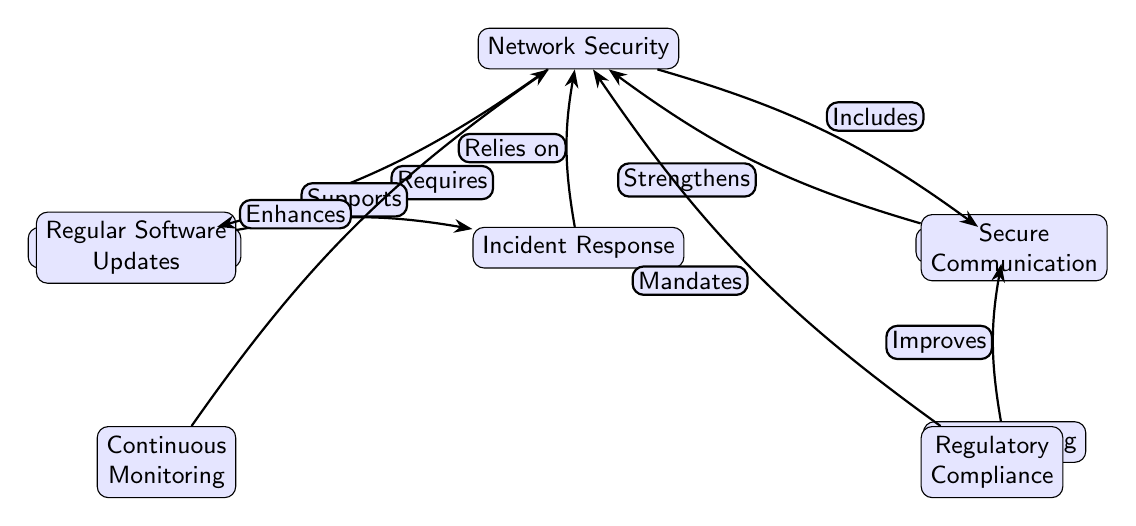What are the components of network security? The diagram identifies two specific components of network security: Device Encryption and Access Control, represented as nodes branching directly from the Network Security node.
Answer: Device Encryption, Access Control How many nodes are there in the diagram? By counting all the distinct elements represented in the diagram, we identify a total of 8 nodes: Network Security, Device Encryption, Access Control, Incident Response, Regular Software Updates, Secure Communication, Continuous Monitoring, User Training, and Regulatory Compliance.
Answer: 8 Which component mandates network security? Compliance is indicated in the diagram as directly linked to Network Security with the label "Mandates," highlighting its role in enforcing security measures within the framework.
Answer: Regulatory Compliance What enhances network security? Continuous Monitoring is directly connected to Network Security with the label "Enhances," suggesting that it plays a significant role in improving the overall security posture.
Answer: Continuous Monitoring Which node relies on incident response? The flowchart shows that Network Security is indicated to "Relies on" Incident Response, implying that incident response practices are crucial for the effective operation of network security measures.
Answer: Network Security How does secure communication relate to network security? The diagram specifies that Secure Communication "Strengthens" Network Security, implying that secure communication protocols contribute to the robustness of the security framework.
Answer: Strengthens What supports incident response? Regular Software Updates is shown in the diagram as contributing to Incident Response with the label "Supports," indicating that keeping software up to date aids effective incident handling.
Answer: Regular Software Updates How does user training affect access control? User Training improves Access Control as indicated by the diagram, which shows a direct link labeled "Improves," meaning that effective training enhances users' ability to adhere to access control protocols.
Answer: Improves 